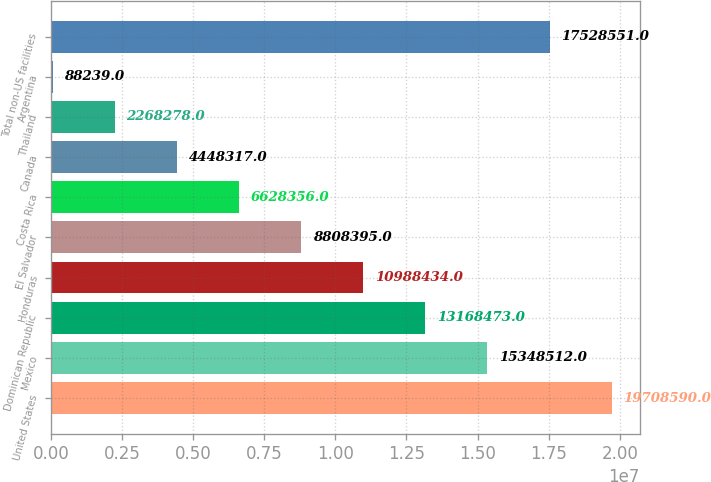Convert chart to OTSL. <chart><loc_0><loc_0><loc_500><loc_500><bar_chart><fcel>United States<fcel>Mexico<fcel>Dominican Republic<fcel>Honduras<fcel>El Salvador<fcel>Costa Rica<fcel>Canada<fcel>Thailand<fcel>Argentina<fcel>Total non-US facilities<nl><fcel>1.97086e+07<fcel>1.53485e+07<fcel>1.31685e+07<fcel>1.09884e+07<fcel>8.8084e+06<fcel>6.62836e+06<fcel>4.44832e+06<fcel>2.26828e+06<fcel>88239<fcel>1.75286e+07<nl></chart> 